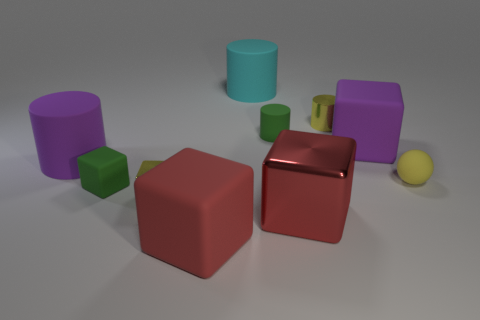Is the color of the tiny rubber cube the same as the small metal cylinder?
Your response must be concise. No. How many objects are either rubber cylinders that are to the left of the red matte cube or tiny green cubes?
Your response must be concise. 2. What number of tiny green rubber things are behind the big matte cylinder that is behind the large purple thing that is to the left of the small green rubber block?
Make the answer very short. 0. Is there anything else that is the same size as the metallic cylinder?
Provide a short and direct response. Yes. The tiny thing right of the small yellow thing behind the big purple thing that is on the right side of the large cyan cylinder is what shape?
Keep it short and to the point. Sphere. How many other things are there of the same color as the small matte sphere?
Your answer should be compact. 2. What is the shape of the green rubber thing that is left of the small rubber cylinder that is to the right of the small green matte block?
Your answer should be compact. Cube. There is a tiny matte cylinder; how many big rubber cubes are right of it?
Keep it short and to the point. 1. Are there any brown cylinders that have the same material as the yellow ball?
Your answer should be very brief. No. There is another cylinder that is the same size as the yellow cylinder; what material is it?
Give a very brief answer. Rubber. 